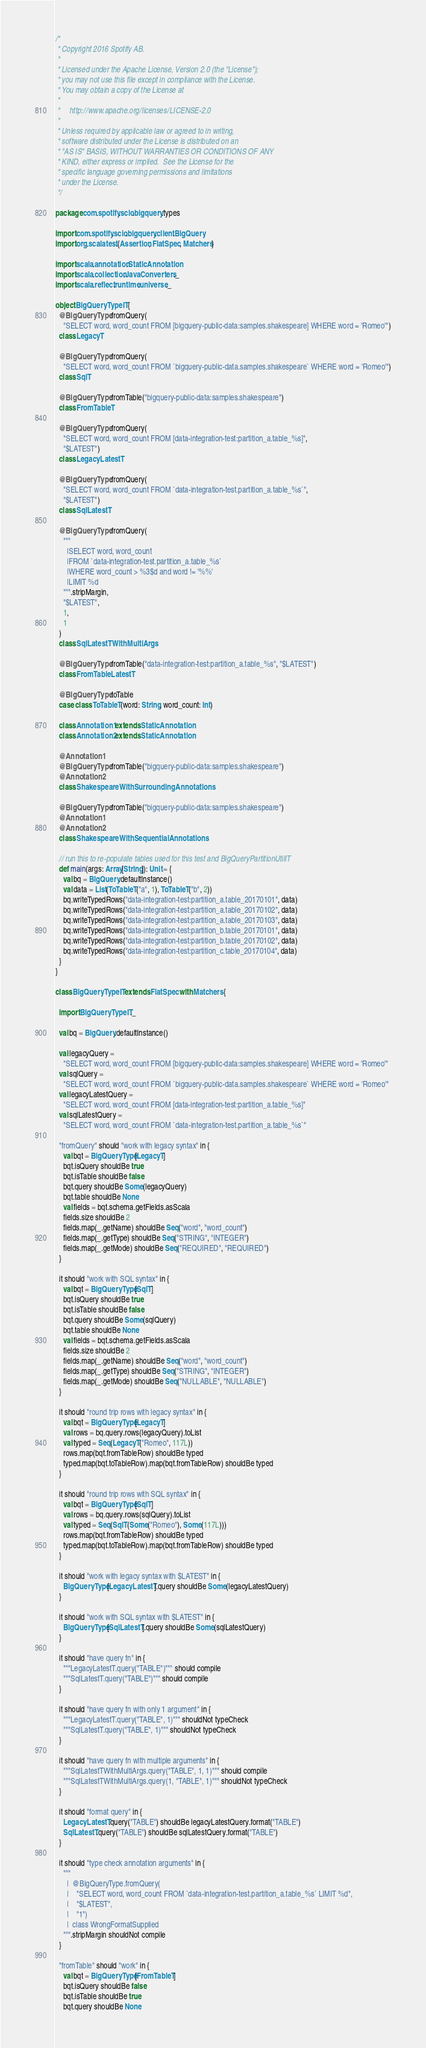Convert code to text. <code><loc_0><loc_0><loc_500><loc_500><_Scala_>/*
 * Copyright 2016 Spotify AB.
 *
 * Licensed under the Apache License, Version 2.0 (the "License");
 * you may not use this file except in compliance with the License.
 * You may obtain a copy of the License at
 *
 *     http://www.apache.org/licenses/LICENSE-2.0
 *
 * Unless required by applicable law or agreed to in writing,
 * software distributed under the License is distributed on an
 * "AS IS" BASIS, WITHOUT WARRANTIES OR CONDITIONS OF ANY
 * KIND, either express or implied.  See the License for the
 * specific language governing permissions and limitations
 * under the License.
 */

package com.spotify.scio.bigquery.types

import com.spotify.scio.bigquery.client.BigQuery
import org.scalatest.{Assertion, FlatSpec, Matchers}

import scala.annotation.StaticAnnotation
import scala.collection.JavaConverters._
import scala.reflect.runtime.universe._

object BigQueryTypeIT {
  @BigQueryType.fromQuery(
    "SELECT word, word_count FROM [bigquery-public-data:samples.shakespeare] WHERE word = 'Romeo'")
  class LegacyT

  @BigQueryType.fromQuery(
    "SELECT word, word_count FROM `bigquery-public-data.samples.shakespeare` WHERE word = 'Romeo'")
  class SqlT

  @BigQueryType.fromTable("bigquery-public-data:samples.shakespeare")
  class FromTableT

  @BigQueryType.fromQuery(
    "SELECT word, word_count FROM [data-integration-test:partition_a.table_%s]",
    "$LATEST")
  class LegacyLatestT

  @BigQueryType.fromQuery(
    "SELECT word, word_count FROM `data-integration-test.partition_a.table_%s`",
    "$LATEST")
  class SqlLatestT

  @BigQueryType.fromQuery(
    """
      |SELECT word, word_count
      |FROM `data-integration-test.partition_a.table_%s`
      |WHERE word_count > %3$d and word != '%%'
      |LIMIT %d
    """.stripMargin,
    "$LATEST",
    1,
    1
  )
  class SqlLatestTWithMultiArgs

  @BigQueryType.fromTable("data-integration-test:partition_a.table_%s", "$LATEST")
  class FromTableLatestT

  @BigQueryType.toTable
  case class ToTableT(word: String, word_count: Int)

  class Annotation1 extends StaticAnnotation
  class Annotation2 extends StaticAnnotation

  @Annotation1
  @BigQueryType.fromTable("bigquery-public-data:samples.shakespeare")
  @Annotation2
  class ShakespeareWithSurroundingAnnotations

  @BigQueryType.fromTable("bigquery-public-data:samples.shakespeare")
  @Annotation1
  @Annotation2
  class ShakespeareWithSequentialAnnotations

  // run this to re-populate tables used for this test and BigQueryPartitionUtilIT
  def main(args: Array[String]): Unit = {
    val bq = BigQuery.defaultInstance()
    val data = List(ToTableT("a", 1), ToTableT("b", 2))
    bq.writeTypedRows("data-integration-test:partition_a.table_20170101", data)
    bq.writeTypedRows("data-integration-test:partition_a.table_20170102", data)
    bq.writeTypedRows("data-integration-test:partition_a.table_20170103", data)
    bq.writeTypedRows("data-integration-test:partition_b.table_20170101", data)
    bq.writeTypedRows("data-integration-test:partition_b.table_20170102", data)
    bq.writeTypedRows("data-integration-test:partition_c.table_20170104", data)
  }
}

class BigQueryTypeIT extends FlatSpec with Matchers {

  import BigQueryTypeIT._

  val bq = BigQuery.defaultInstance()

  val legacyQuery =
    "SELECT word, word_count FROM [bigquery-public-data:samples.shakespeare] WHERE word = 'Romeo'"
  val sqlQuery =
    "SELECT word, word_count FROM `bigquery-public-data.samples.shakespeare` WHERE word = 'Romeo'"
  val legacyLatestQuery =
    "SELECT word, word_count FROM [data-integration-test:partition_a.table_%s]"
  val sqlLatestQuery =
    "SELECT word, word_count FROM `data-integration-test.partition_a.table_%s`"

  "fromQuery" should "work with legacy syntax" in {
    val bqt = BigQueryType[LegacyT]
    bqt.isQuery shouldBe true
    bqt.isTable shouldBe false
    bqt.query shouldBe Some(legacyQuery)
    bqt.table shouldBe None
    val fields = bqt.schema.getFields.asScala
    fields.size shouldBe 2
    fields.map(_.getName) shouldBe Seq("word", "word_count")
    fields.map(_.getType) shouldBe Seq("STRING", "INTEGER")
    fields.map(_.getMode) shouldBe Seq("REQUIRED", "REQUIRED")
  }

  it should "work with SQL syntax" in {
    val bqt = BigQueryType[SqlT]
    bqt.isQuery shouldBe true
    bqt.isTable shouldBe false
    bqt.query shouldBe Some(sqlQuery)
    bqt.table shouldBe None
    val fields = bqt.schema.getFields.asScala
    fields.size shouldBe 2
    fields.map(_.getName) shouldBe Seq("word", "word_count")
    fields.map(_.getType) shouldBe Seq("STRING", "INTEGER")
    fields.map(_.getMode) shouldBe Seq("NULLABLE", "NULLABLE")
  }

  it should "round trip rows with legacy syntax" in {
    val bqt = BigQueryType[LegacyT]
    val rows = bq.query.rows(legacyQuery).toList
    val typed = Seq(LegacyT("Romeo", 117L))
    rows.map(bqt.fromTableRow) shouldBe typed
    typed.map(bqt.toTableRow).map(bqt.fromTableRow) shouldBe typed
  }

  it should "round trip rows with SQL syntax" in {
    val bqt = BigQueryType[SqlT]
    val rows = bq.query.rows(sqlQuery).toList
    val typed = Seq(SqlT(Some("Romeo"), Some(117L)))
    rows.map(bqt.fromTableRow) shouldBe typed
    typed.map(bqt.toTableRow).map(bqt.fromTableRow) shouldBe typed
  }

  it should "work with legacy syntax with $LATEST" in {
    BigQueryType[LegacyLatestT].query shouldBe Some(legacyLatestQuery)
  }

  it should "work with SQL syntax with $LATEST" in {
    BigQueryType[SqlLatestT].query shouldBe Some(sqlLatestQuery)
  }

  it should "have query fn" in {
    """LegacyLatestT.query("TABLE")""" should compile
    """SqlLatestT.query("TABLE")""" should compile
  }

  it should "have query fn with only 1 argument" in {
    """LegacyLatestT.query("TABLE", 1)""" shouldNot typeCheck
    """SqlLatestT.query("TABLE", 1)""" shouldNot typeCheck
  }

  it should "have query fn with multiple arguments" in {
    """SqlLatestTWithMultiArgs.query("TABLE", 1, 1)""" should compile
    """SqlLatestTWithMultiArgs.query(1, "TABLE", 1)""" shouldNot typeCheck
  }

  it should "format query" in {
    LegacyLatestT.query("TABLE") shouldBe legacyLatestQuery.format("TABLE")
    SqlLatestT.query("TABLE") shouldBe sqlLatestQuery.format("TABLE")
  }

  it should "type check annotation arguments" in {
    """
      |  @BigQueryType.fromQuery(
      |    "SELECT word, word_count FROM `data-integration-test.partition_a.table_%s` LIMIT %d",
      |    "$LATEST",
      |    "1")
      |  class WrongFormatSupplied
    """.stripMargin shouldNot compile
  }

  "fromTable" should "work" in {
    val bqt = BigQueryType[FromTableT]
    bqt.isQuery shouldBe false
    bqt.isTable shouldBe true
    bqt.query shouldBe None</code> 